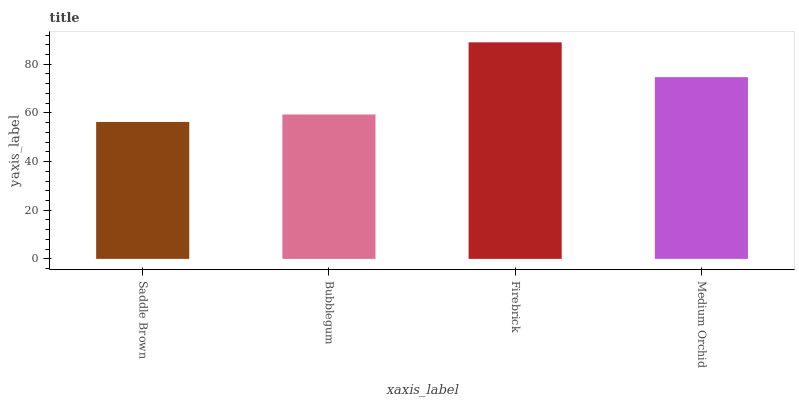Is Saddle Brown the minimum?
Answer yes or no. Yes. Is Firebrick the maximum?
Answer yes or no. Yes. Is Bubblegum the minimum?
Answer yes or no. No. Is Bubblegum the maximum?
Answer yes or no. No. Is Bubblegum greater than Saddle Brown?
Answer yes or no. Yes. Is Saddle Brown less than Bubblegum?
Answer yes or no. Yes. Is Saddle Brown greater than Bubblegum?
Answer yes or no. No. Is Bubblegum less than Saddle Brown?
Answer yes or no. No. Is Medium Orchid the high median?
Answer yes or no. Yes. Is Bubblegum the low median?
Answer yes or no. Yes. Is Firebrick the high median?
Answer yes or no. No. Is Saddle Brown the low median?
Answer yes or no. No. 